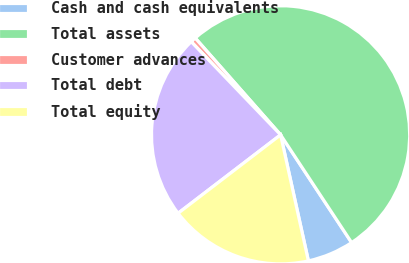Convert chart. <chart><loc_0><loc_0><loc_500><loc_500><pie_chart><fcel>Cash and cash equivalents<fcel>Total assets<fcel>Customer advances<fcel>Total debt<fcel>Total equity<nl><fcel>5.82%<fcel>52.23%<fcel>0.67%<fcel>23.22%<fcel>18.06%<nl></chart> 